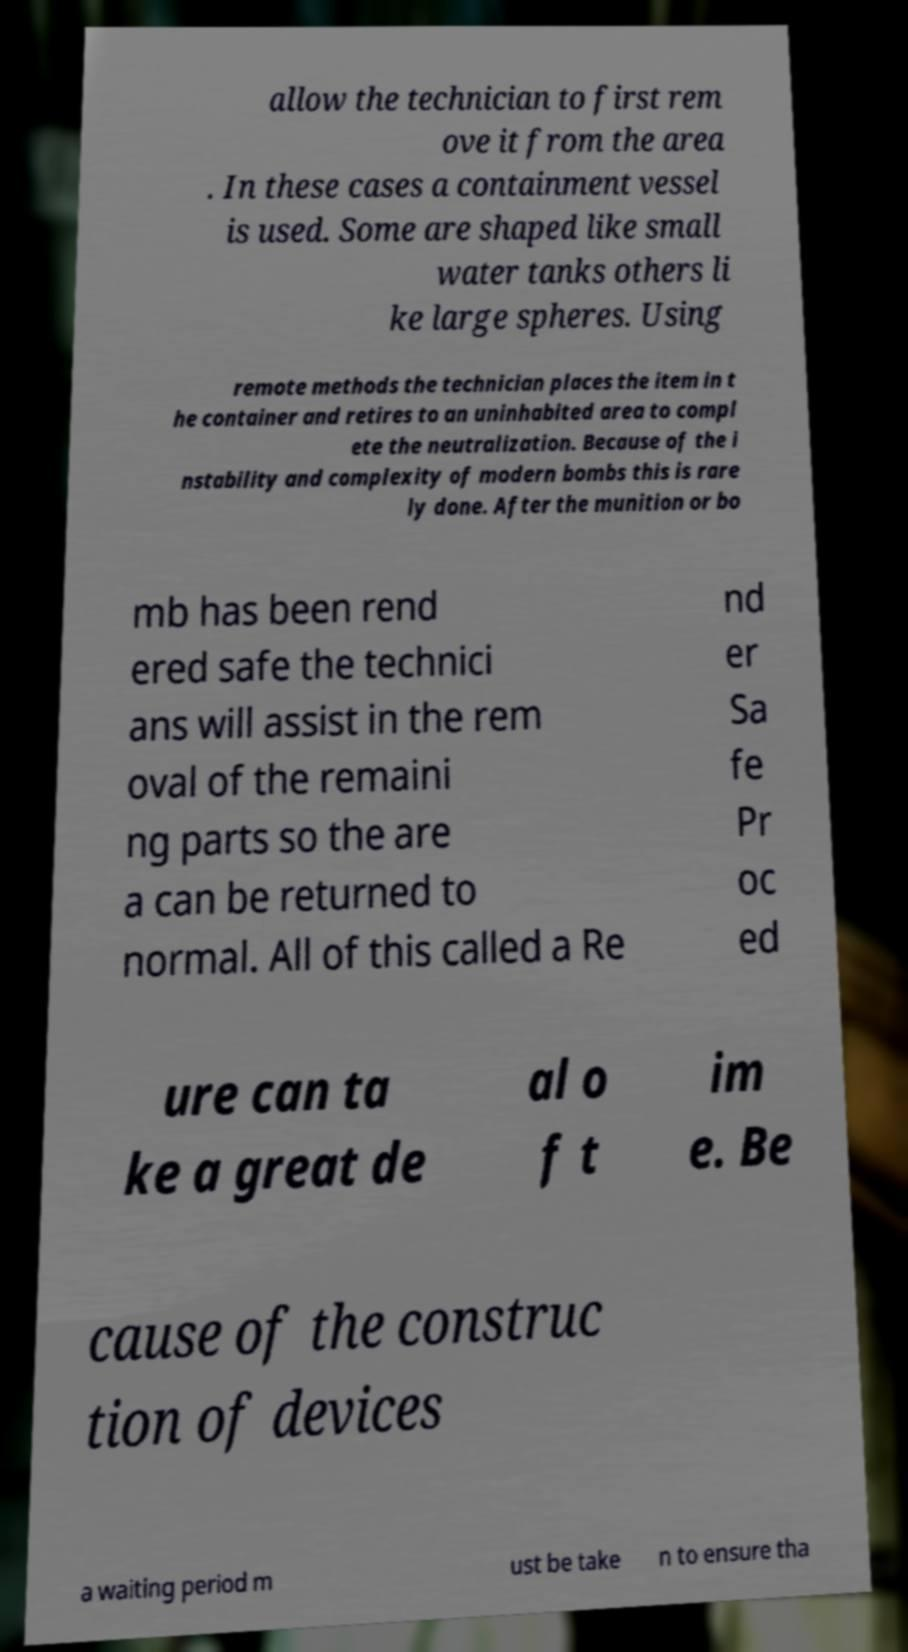Can you read and provide the text displayed in the image?This photo seems to have some interesting text. Can you extract and type it out for me? allow the technician to first rem ove it from the area . In these cases a containment vessel is used. Some are shaped like small water tanks others li ke large spheres. Using remote methods the technician places the item in t he container and retires to an uninhabited area to compl ete the neutralization. Because of the i nstability and complexity of modern bombs this is rare ly done. After the munition or bo mb has been rend ered safe the technici ans will assist in the rem oval of the remaini ng parts so the are a can be returned to normal. All of this called a Re nd er Sa fe Pr oc ed ure can ta ke a great de al o f t im e. Be cause of the construc tion of devices a waiting period m ust be take n to ensure tha 